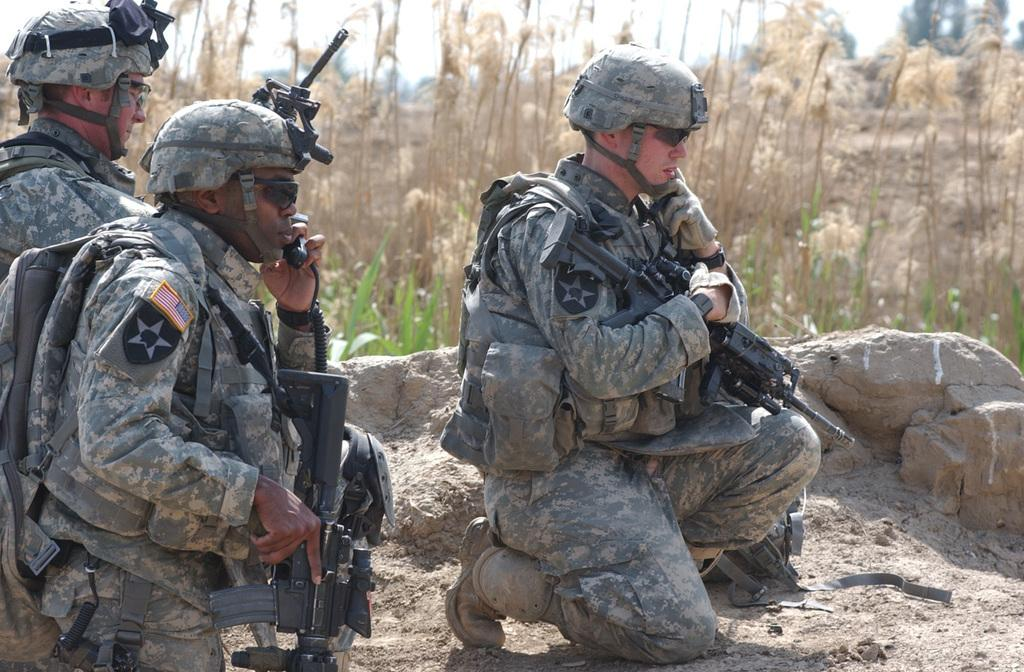How many people are in the image? There are three persons in the image. What are the persons wearing on their heads? The persons are wearing helmets. What are the persons holding in their hands? The persons are holding rifles. What type of natural elements can be seen in the image? There are stones, plants, trees, and the sky visible in the image. Can you touch the jelly that is floating in the sky in the image? There is no jelly present in the image, and the sky is not depicted as a tangible object that can be touched. 